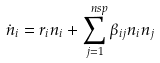<formula> <loc_0><loc_0><loc_500><loc_500>\dot { n } _ { i } = r _ { i } n _ { i } + \sum _ { j = 1 } ^ { \ n s p } \beta _ { i j } n _ { i } n _ { j }</formula> 